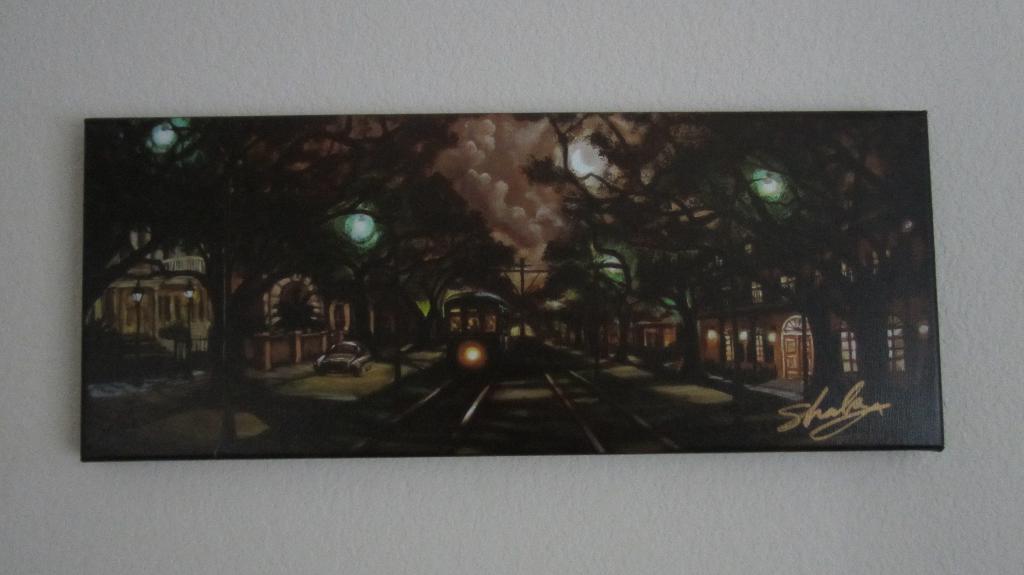Is there a signature on the artwork?
Keep it short and to the point. Yes. This is a portrait of what?
Provide a short and direct response. Answering does not require reading text in the image. 